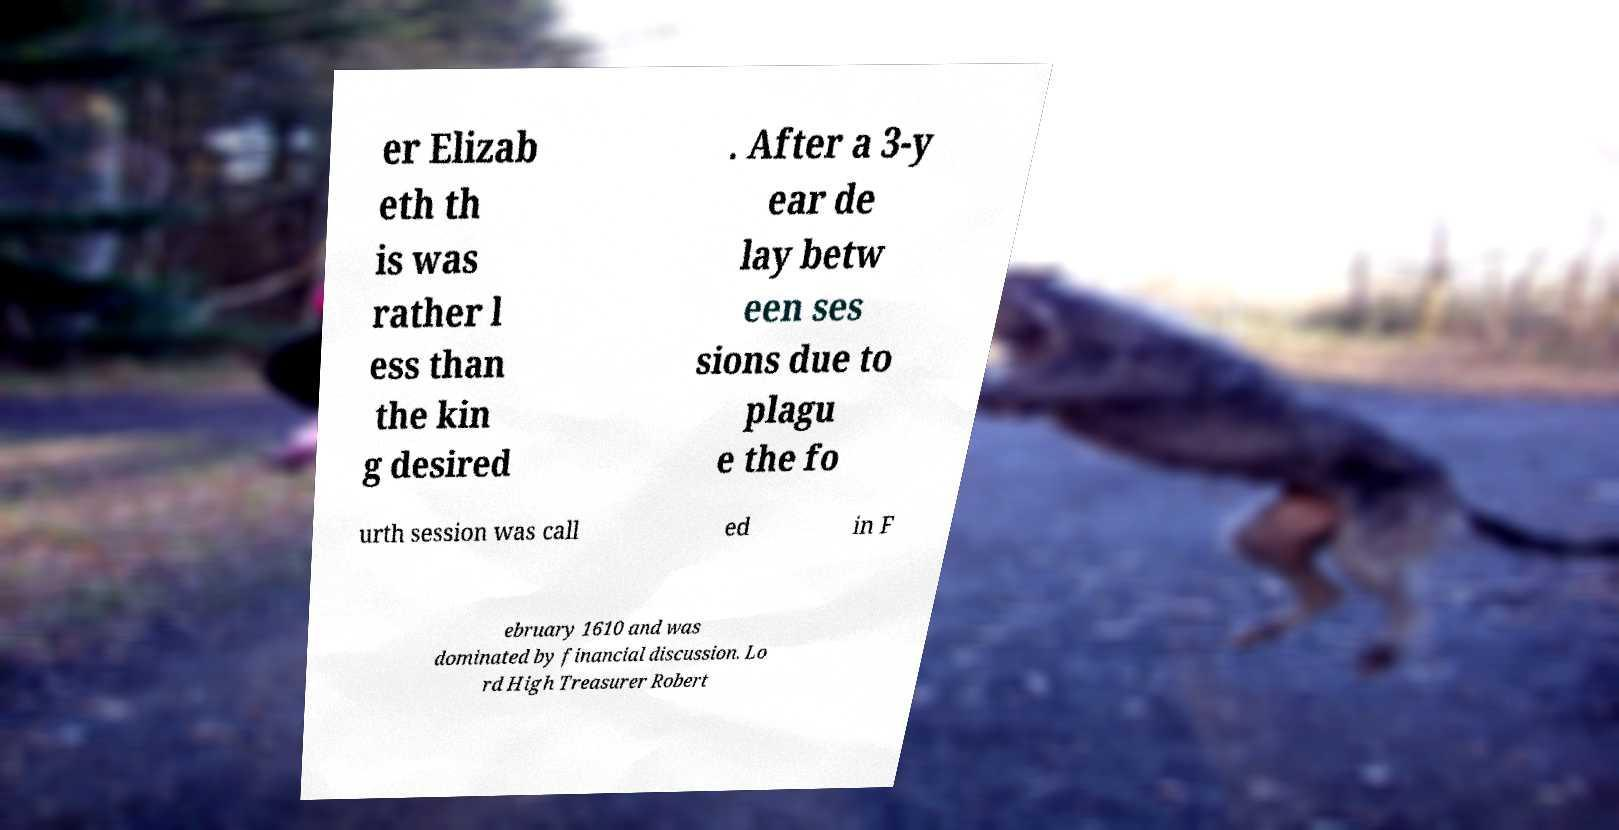Please read and relay the text visible in this image. What does it say? er Elizab eth th is was rather l ess than the kin g desired . After a 3-y ear de lay betw een ses sions due to plagu e the fo urth session was call ed in F ebruary 1610 and was dominated by financial discussion. Lo rd High Treasurer Robert 